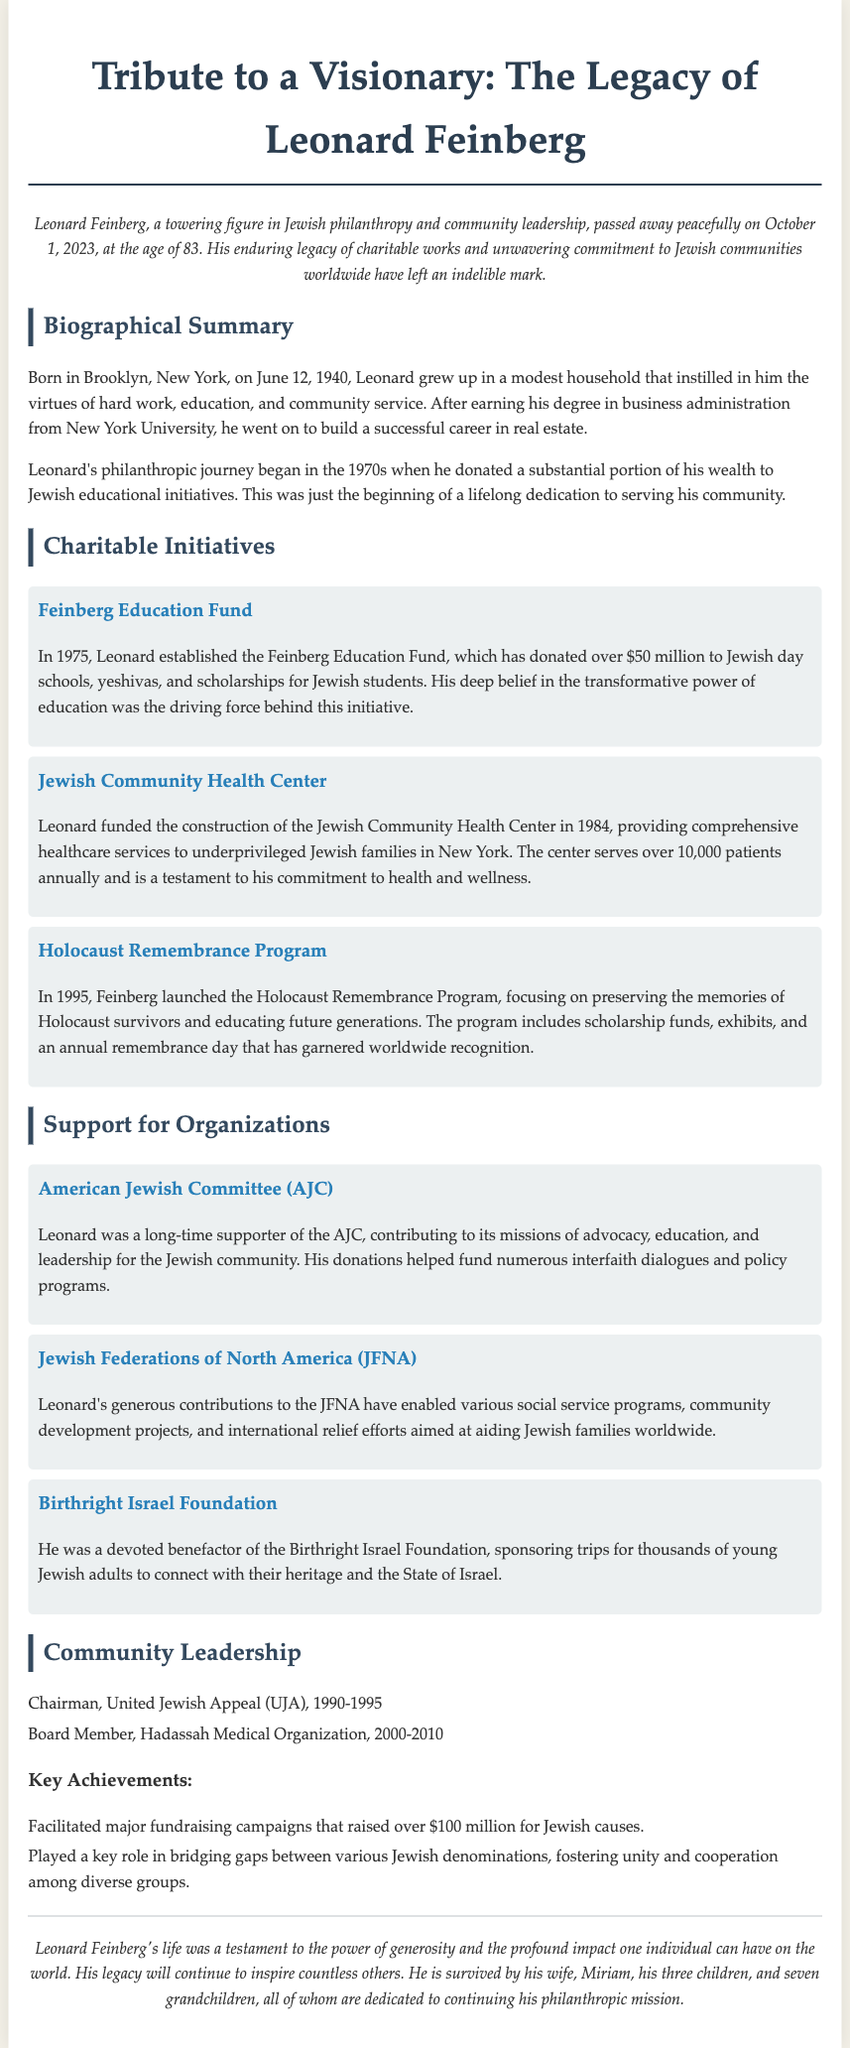What was Leonard Feinberg's age at the time of his passing? The obituary states that Leonard Feinberg passed away at the age of 83.
Answer: 83 What year was the Feinberg Education Fund established? The document mentions that the Feinberg Education Fund was established in 1975.
Answer: 1975 How much money did the Feinberg Education Fund donate to educational initiatives? The document indicates that the Feinberg Education Fund donated over $50 million.
Answer: over $50 million What healthcare facility did Leonard Feinberg fund in 1984? The obituary notes that he funded the construction of the Jewish Community Health Center.
Answer: Jewish Community Health Center Which organization did Leonard support that focuses on advocacy for the Jewish community? The American Jewish Committee (AJC) is the organization mentioned that focuses on advocacy.
Answer: American Jewish Committee (AJC) What were Leonard’s years of service as Chairman of the United Jewish Appeal (UJA)? The document states that he served from 1990 to 1995.
Answer: 1990-1995 How many grandchildren did Leonard Feinberg have? The obituary mentions that he is survived by seven grandchildren.
Answer: seven What major achievement involved raising over $100 million? The major fundraising campaigns facilitated by Leonard raised over $100 million for Jewish causes.
Answer: over $100 million What was the focus of the Holocaust Remembrance Program launched in 1995? The document describes the program as focusing on preserving the memories of Holocaust survivors and educating future generations.
Answer: preserving the memories of Holocaust survivors 